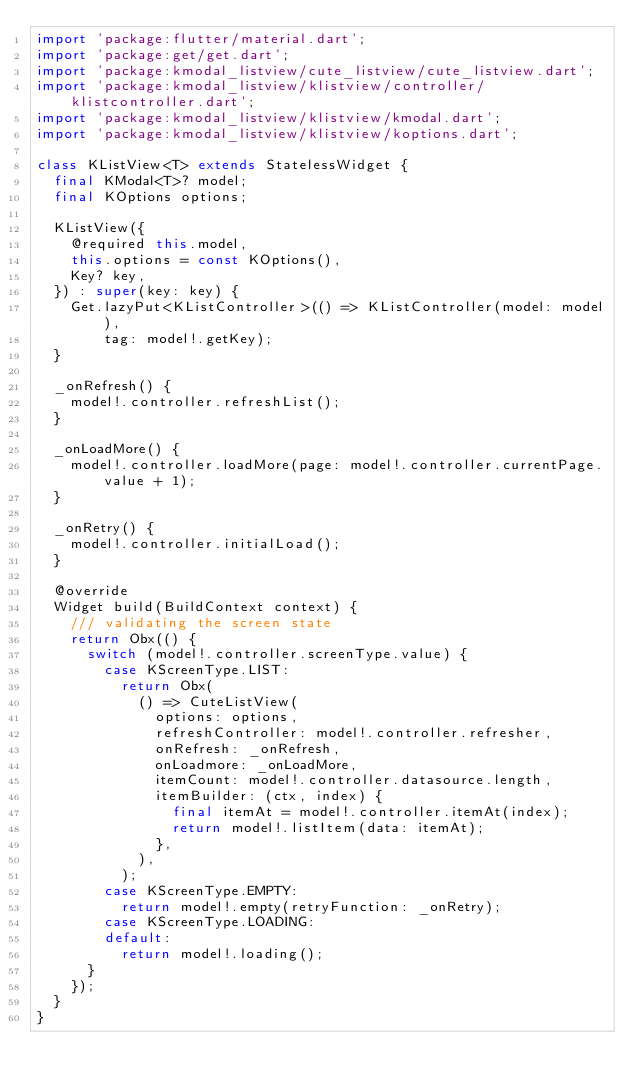<code> <loc_0><loc_0><loc_500><loc_500><_Dart_>import 'package:flutter/material.dart';
import 'package:get/get.dart';
import 'package:kmodal_listview/cute_listview/cute_listview.dart';
import 'package:kmodal_listview/klistview/controller/klistcontroller.dart';
import 'package:kmodal_listview/klistview/kmodal.dart';
import 'package:kmodal_listview/klistview/koptions.dart';

class KListView<T> extends StatelessWidget {
  final KModal<T>? model;
  final KOptions options;

  KListView({
    @required this.model,
    this.options = const KOptions(),
    Key? key,
  }) : super(key: key) {
    Get.lazyPut<KListController>(() => KListController(model: model),
        tag: model!.getKey);
  }

  _onRefresh() {
    model!.controller.refreshList();
  }

  _onLoadMore() {
    model!.controller.loadMore(page: model!.controller.currentPage.value + 1);
  }

  _onRetry() {
    model!.controller.initialLoad();
  }

  @override
  Widget build(BuildContext context) {
    /// validating the screen state
    return Obx(() {
      switch (model!.controller.screenType.value) {
        case KScreenType.LIST:
          return Obx(
            () => CuteListView(
              options: options,
              refreshController: model!.controller.refresher,
              onRefresh: _onRefresh,
              onLoadmore: _onLoadMore,
              itemCount: model!.controller.datasource.length,
              itemBuilder: (ctx, index) {
                final itemAt = model!.controller.itemAt(index);
                return model!.listItem(data: itemAt);
              },
            ),
          );
        case KScreenType.EMPTY:
          return model!.empty(retryFunction: _onRetry);
        case KScreenType.LOADING:
        default:
          return model!.loading();
      }
    });
  }
}
</code> 